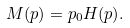Convert formula to latex. <formula><loc_0><loc_0><loc_500><loc_500>M ( { p } ) = p _ { 0 } H ( { p } ) .</formula> 